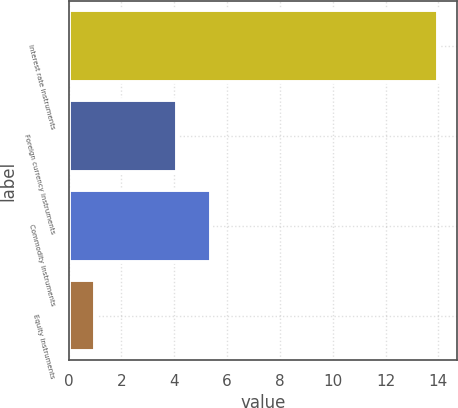<chart> <loc_0><loc_0><loc_500><loc_500><bar_chart><fcel>Interest rate instruments<fcel>Foreign currency instruments<fcel>Commodity instruments<fcel>Equity instruments<nl><fcel>14<fcel>4.1<fcel>5.4<fcel>1<nl></chart> 